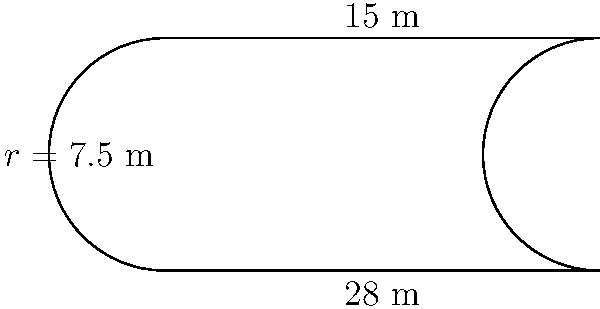A basketball court has rectangular middle section with semicircular ends. The width of the court is $15$ m and the length of the rectangular section is $28$ m. Calculate the perimeter of the entire court to the nearest meter. To find the perimeter, we need to calculate the sum of the lengths of the straight sides and the curved sections:

1) The width of the court is $15$ m, so the radius of each semicircle is $r = 15/2 = 7.5$ m.

2) The straight sides:
   - Two lengths of $28$ m each: $2 \times 28 = 56$ m

3) The curved sections:
   - We have two semicircles.
   - The circumference of a full circle is $2\pi r$.
   - For a semicircle, it's half of that: $\pi r$.
   - With two semicircles: $2 \times \pi r = 2\pi r = 2\pi(7.5) = 15\pi$ m

4) Total perimeter:
   $$ \text{Perimeter} = 56 + 15\pi \approx 103.14 \text{ m} $$

5) Rounding to the nearest meter:
   $$ \text{Perimeter} \approx 103 \text{ m} $$
Answer: $103$ m 